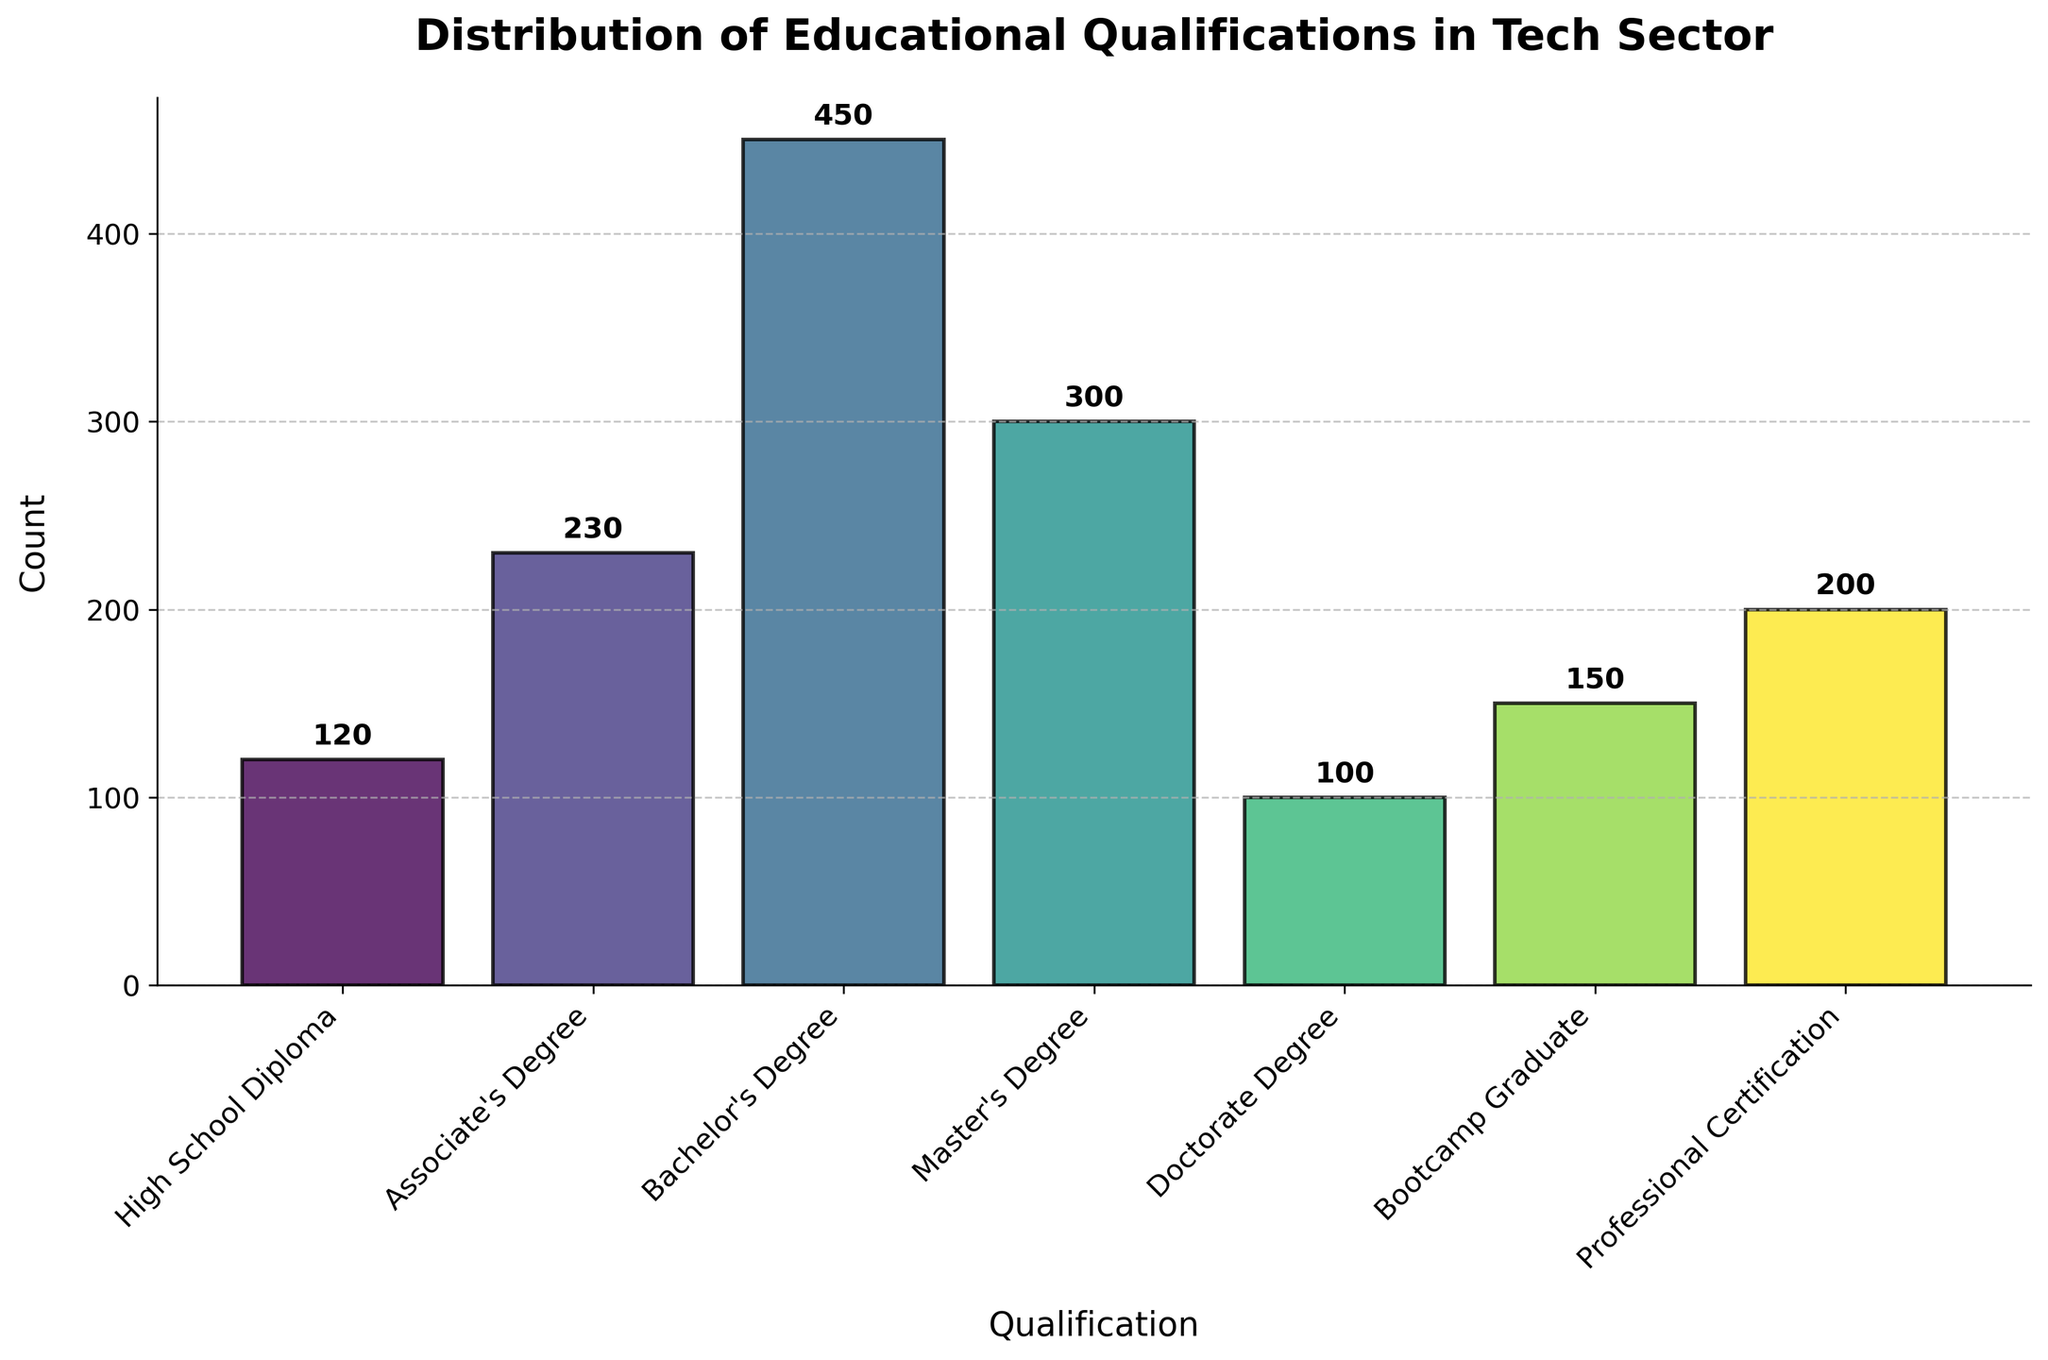What's the title of the figure? The title of the figure is displayed at the top and reads "Distribution of Educational Qualifications in Tech Sector"
Answer: Distribution of Educational Qualifications in Tech Sector How many qualifications are shown in the figure? By counting the different bars or qualifications categorized on the x-axis, we can determine that there are 7 qualifications listed.
Answer: 7 Which qualification has the highest count? The height of the bars represents the count. The tallest bar corresponds to the "Bachelor's Degree", which is the qualification with the highest count.
Answer: Bachelor's Degree What is the count for the Master's Degree qualification? The figure has a label at the top of the bar for each respective qualification. The label on top of the "Master's Degree" bar shows the count as 300.
Answer: 300 What is the average count of all qualifications? To find the average, sum all the counts and divide by the number of qualifications. Sum = 120 + 230 + 450 + 300 + 100 + 150 + 200 = 1550. Number of qualifications = 7. Average = 1550 / 7 ≈ 221.43
Answer: 221.43 Which two qualifications have the same count? By examining the figure, we can see that no two qualifications have exactly the same count.
Answer: None Are there any counts below 150? If so, which qualifications fall under this category? By looking at the heights of the bars and the labels on top, we see that "High School Diploma" (120) and "Doctorate Degree" (100) are below 150.
Answer: High School Diploma, Doctorate Degree How much higher is the count for Bachelor's Degree than for Doctorate Degree? To find this, subtract the count for Doctorate Degree (100) from the count for Bachelor's Degree (450). 450 - 100 = 350
Answer: 350 Which qualification has the median count? To find the median, we need to order the counts: 100, 120, 150, 200, 230, 300, 450. The median value is in the 4th position, which corresponds to the "Professional Certification" with a count of 200.
Answer: Professional Certification If the counts for Associate's Degree and Bachelor's Degree were combined, what would the total be? Sum the counts for Associate's Degree (230) and Bachelor's Degree (450). 230 + 450 = 680
Answer: 680 